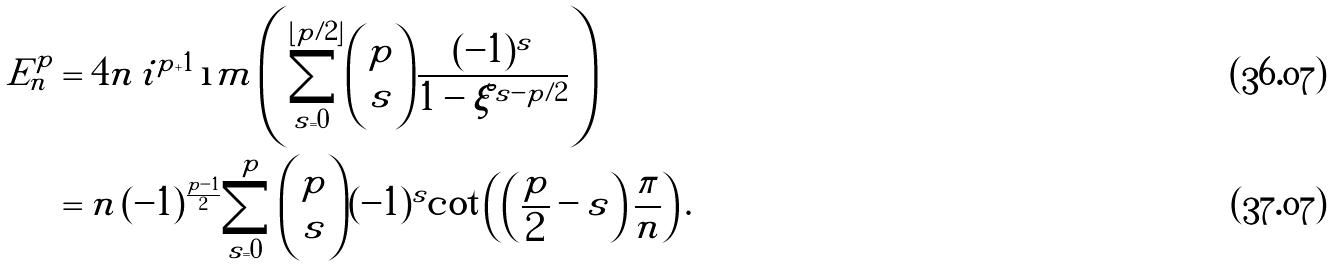<formula> <loc_0><loc_0><loc_500><loc_500>E ^ { p } _ { n } & = 4 n \, i ^ { p + 1 } \, \i m \left ( \sum _ { s = 0 } ^ { \lfloor p / 2 \rfloor } \binom { p } { s } \frac { ( - 1 ) ^ { s } } { 1 - \xi ^ { s - p / 2 } } \right ) \\ & = n \, ( - 1 ) ^ { \frac { p - 1 } { 2 } } \sum _ { s = 0 } ^ { p } \binom { p } { s } ( - 1 ) ^ { s } \cot \left ( \left ( \frac { p } { 2 } - s \right ) \frac { \pi } { n } \right ) .</formula> 